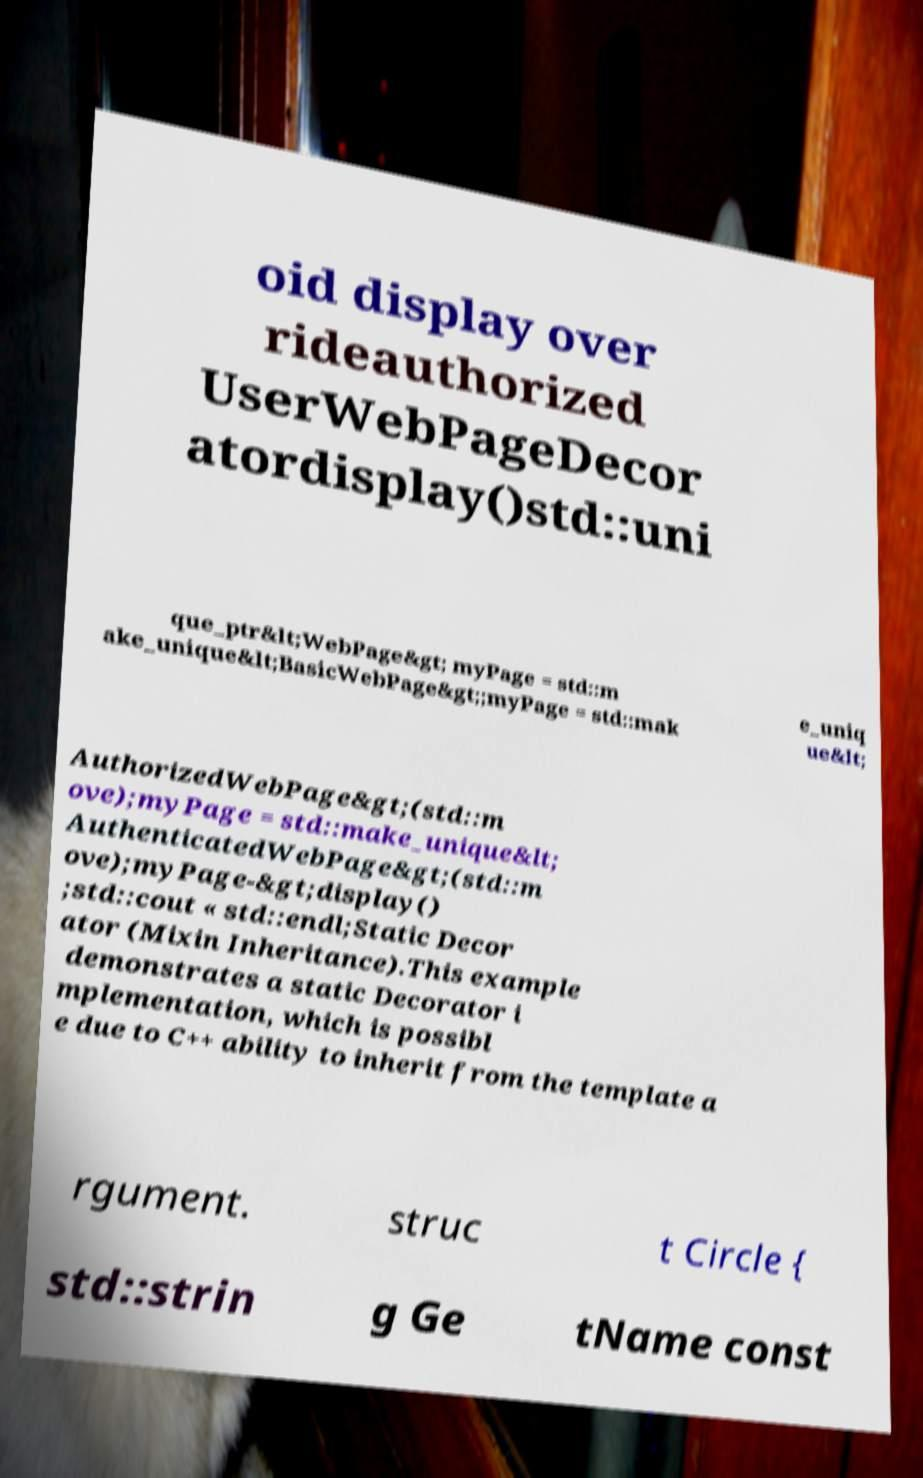Can you accurately transcribe the text from the provided image for me? oid display over rideauthorized UserWebPageDecor atordisplay()std::uni que_ptr&lt;WebPage&gt; myPage = std::m ake_unique&lt;BasicWebPage&gt;;myPage = std::mak e_uniq ue&lt; AuthorizedWebPage&gt;(std::m ove);myPage = std::make_unique&lt; AuthenticatedWebPage&gt;(std::m ove);myPage-&gt;display() ;std::cout « std::endl;Static Decor ator (Mixin Inheritance).This example demonstrates a static Decorator i mplementation, which is possibl e due to C++ ability to inherit from the template a rgument. struc t Circle { std::strin g Ge tName const 